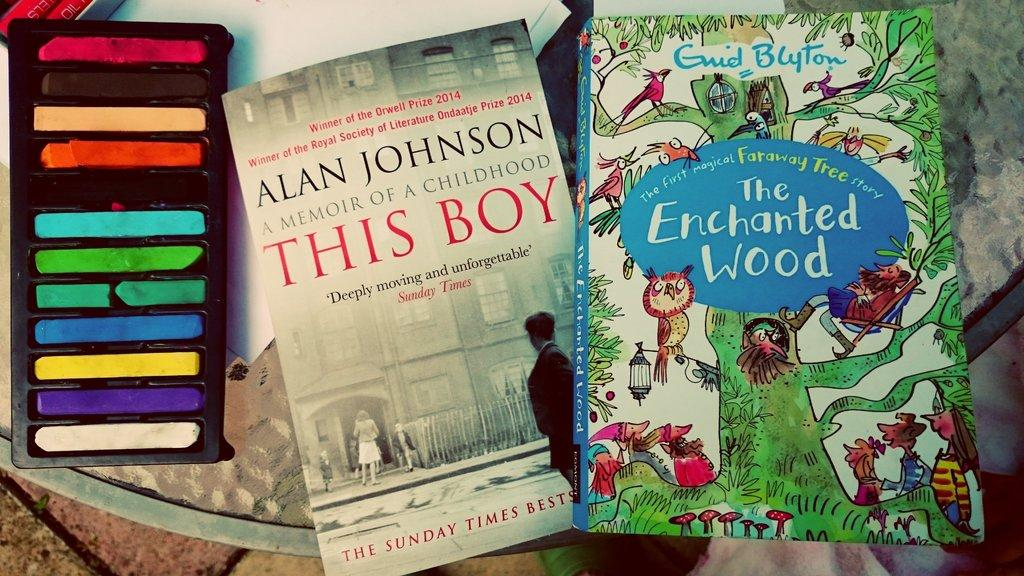<image>
Describe the image concisely. A couple of books on an outside table titled This Boy and The Enchanted Wood 